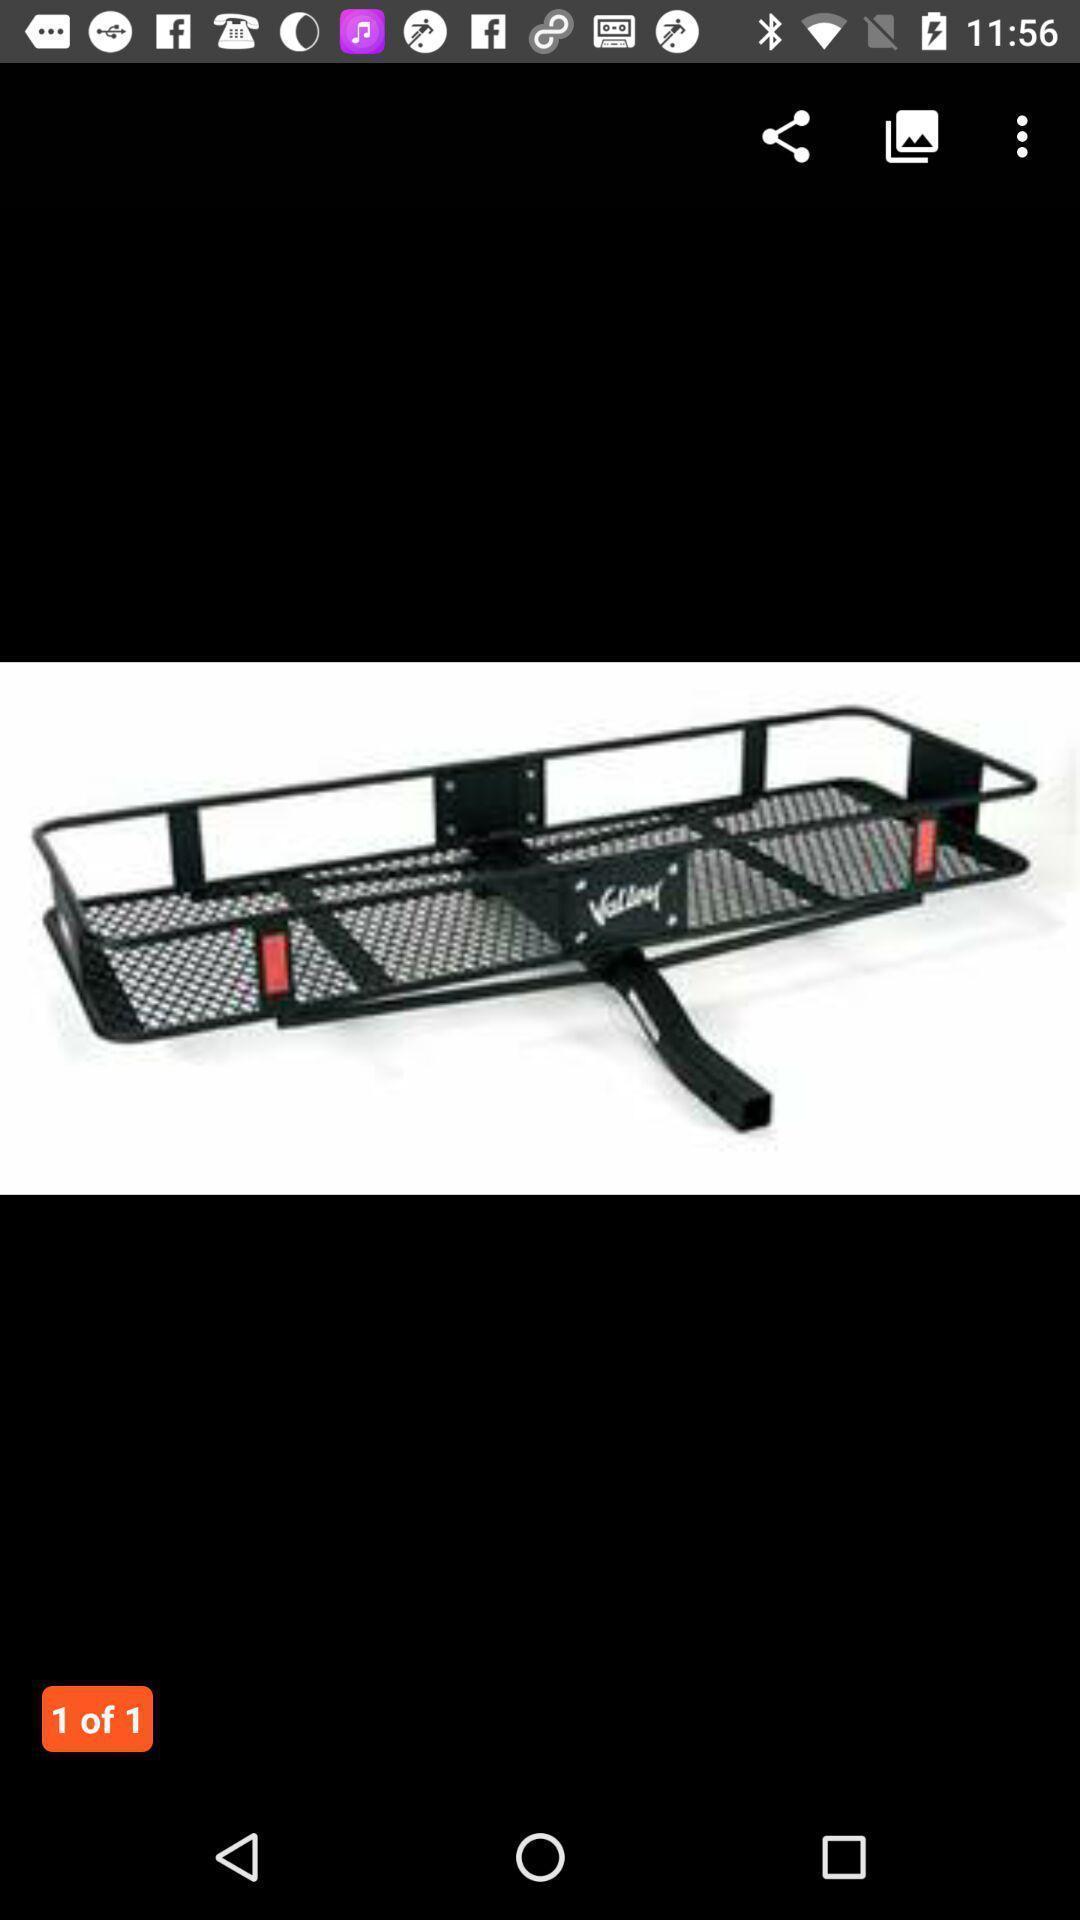Describe this image in words. Window displaying an image which can be shared. 